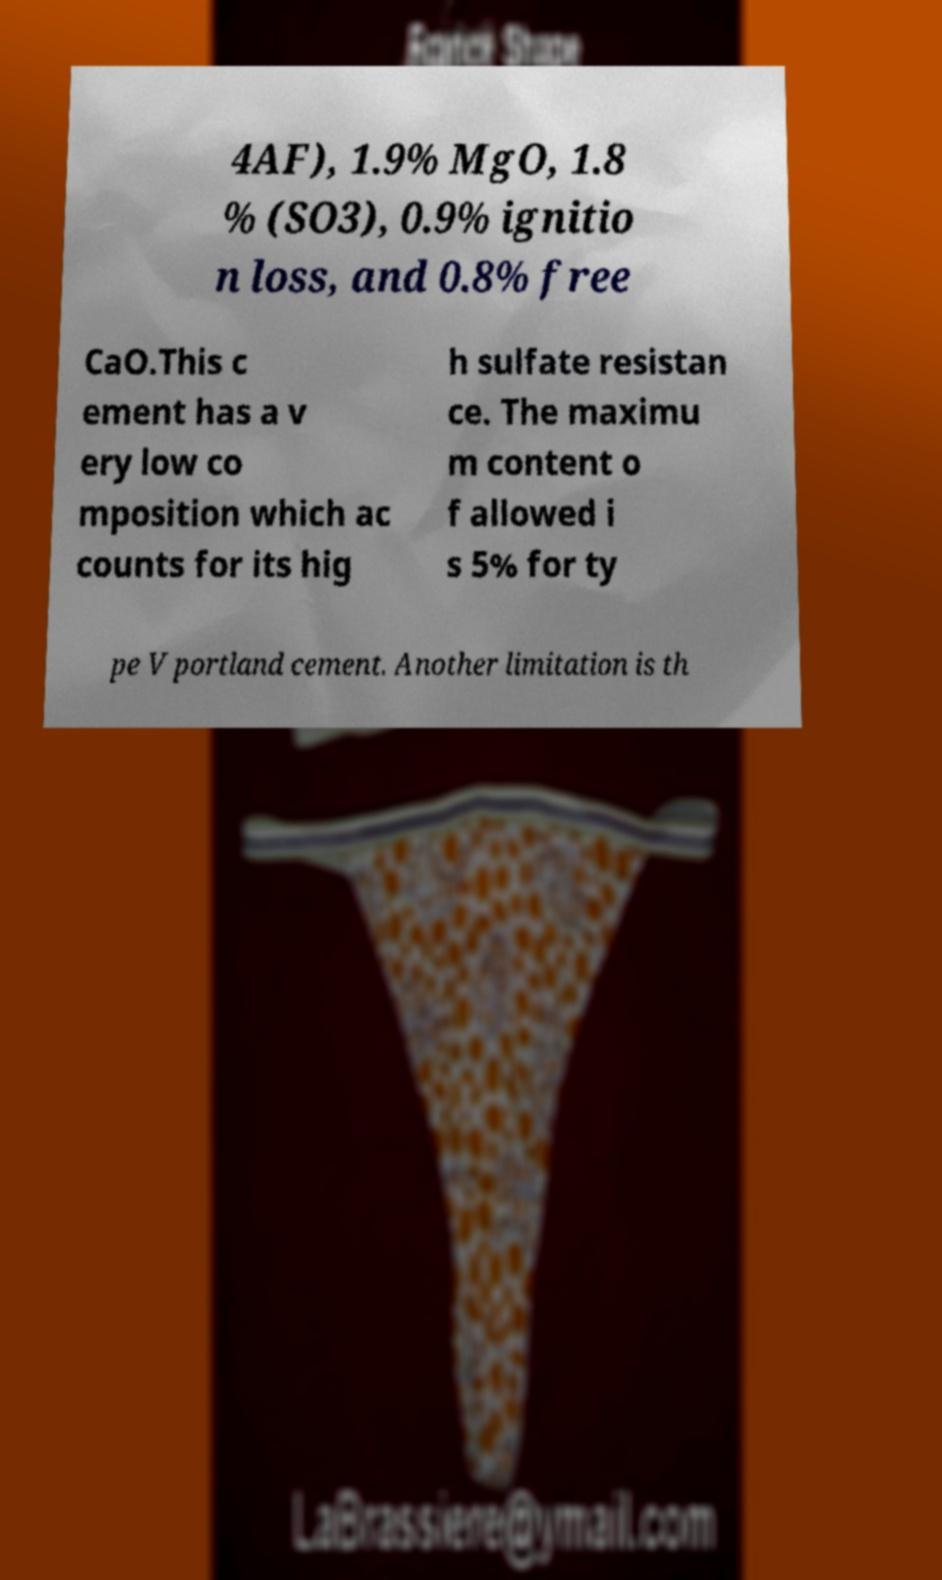Could you assist in decoding the text presented in this image and type it out clearly? 4AF), 1.9% MgO, 1.8 % (SO3), 0.9% ignitio n loss, and 0.8% free CaO.This c ement has a v ery low co mposition which ac counts for its hig h sulfate resistan ce. The maximu m content o f allowed i s 5% for ty pe V portland cement. Another limitation is th 